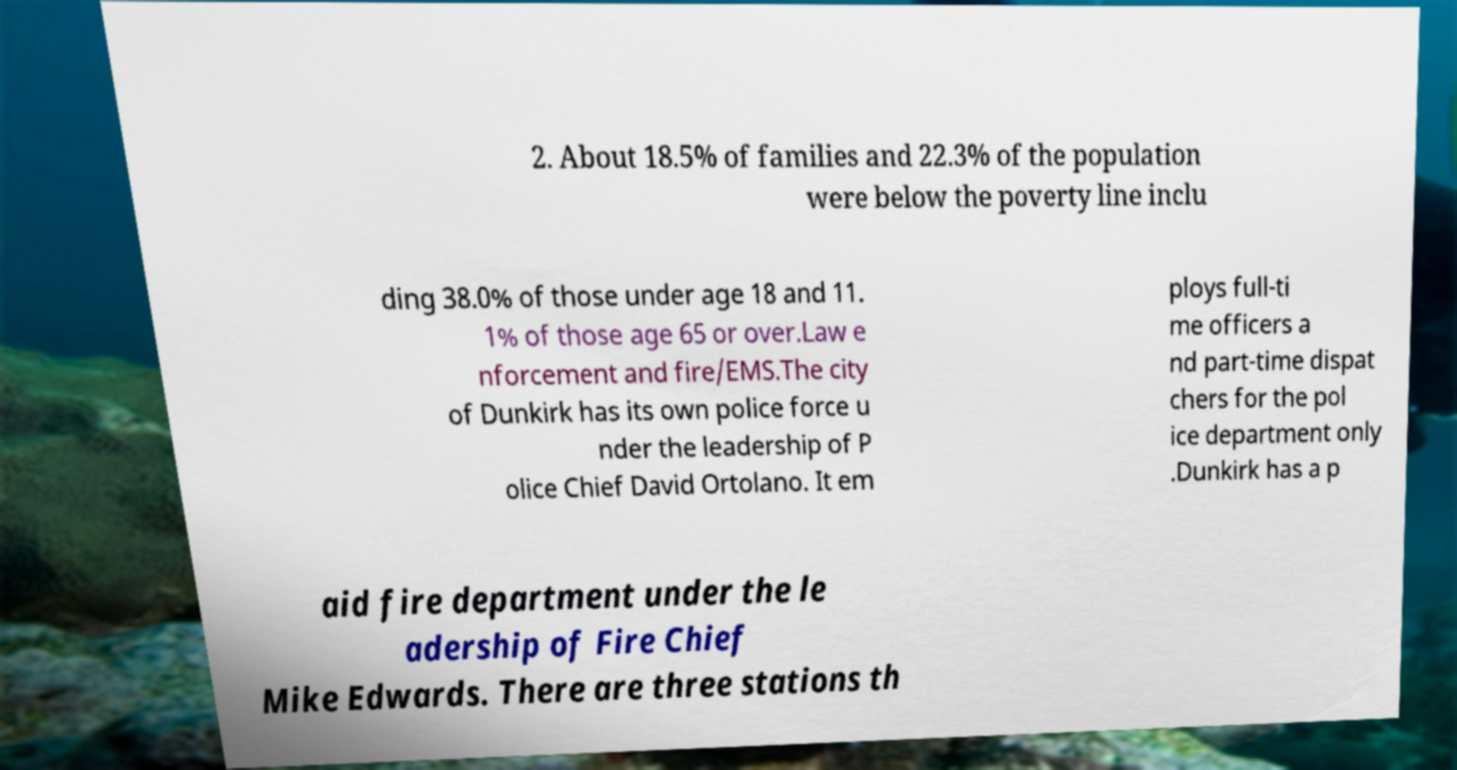Could you assist in decoding the text presented in this image and type it out clearly? 2. About 18.5% of families and 22.3% of the population were below the poverty line inclu ding 38.0% of those under age 18 and 11. 1% of those age 65 or over.Law e nforcement and fire/EMS.The city of Dunkirk has its own police force u nder the leadership of P olice Chief David Ortolano. It em ploys full-ti me officers a nd part-time dispat chers for the pol ice department only .Dunkirk has a p aid fire department under the le adership of Fire Chief Mike Edwards. There are three stations th 